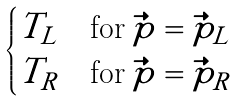Convert formula to latex. <formula><loc_0><loc_0><loc_500><loc_500>\begin{cases} T _ { L } & \text {for} \, \vec { p } = \vec { p } _ { L } \\ T _ { R } & \text {for} \, \vec { p } = \vec { p } _ { R } \end{cases}</formula> 